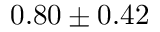<formula> <loc_0><loc_0><loc_500><loc_500>0 . 8 0 \pm 0 . 4 2</formula> 